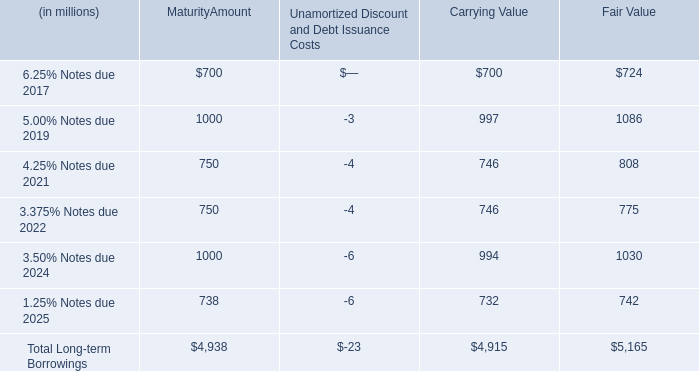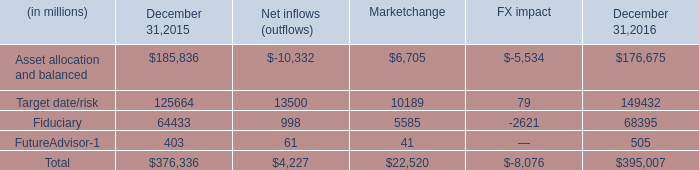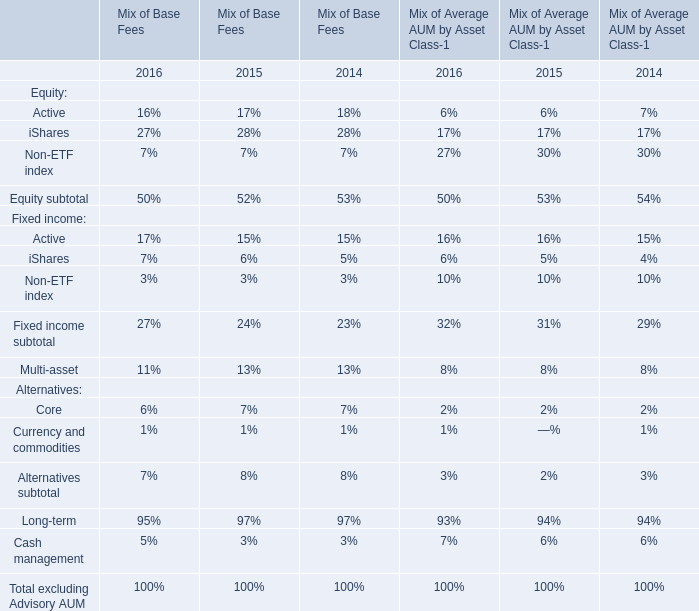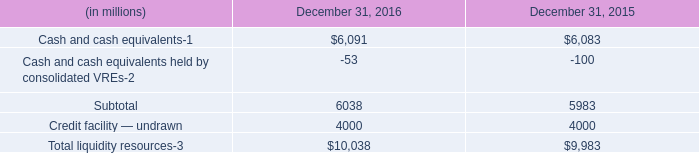what is the average price of the repurchased shares during 2016? 
Computations: ((1.1 * 1000) / 3.3)
Answer: 333.33333. 